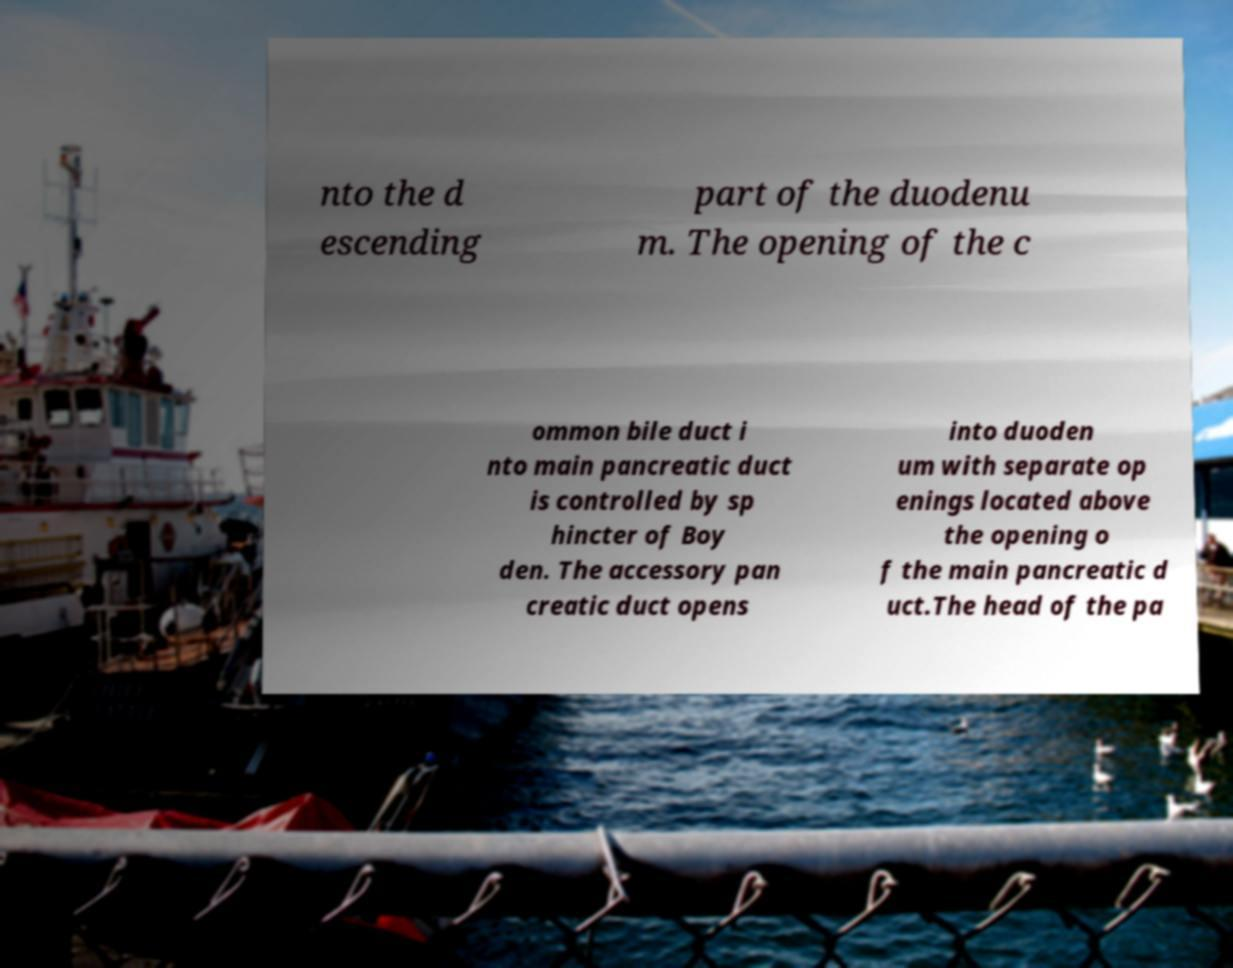For documentation purposes, I need the text within this image transcribed. Could you provide that? nto the d escending part of the duodenu m. The opening of the c ommon bile duct i nto main pancreatic duct is controlled by sp hincter of Boy den. The accessory pan creatic duct opens into duoden um with separate op enings located above the opening o f the main pancreatic d uct.The head of the pa 